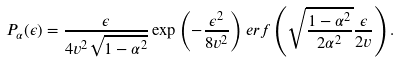Convert formula to latex. <formula><loc_0><loc_0><loc_500><loc_500>P _ { \alpha } ( \epsilon ) = \frac { \epsilon } { 4 v ^ { 2 } \sqrt { 1 - \alpha ^ { 2 } } } \exp \left ( - \frac { \epsilon ^ { 2 } } { 8 v ^ { 2 } } \right ) e r f \left ( \sqrt { \frac { 1 - \alpha ^ { 2 } } { 2 \alpha ^ { 2 } } } \frac { \epsilon } { 2 v } \right ) .</formula> 